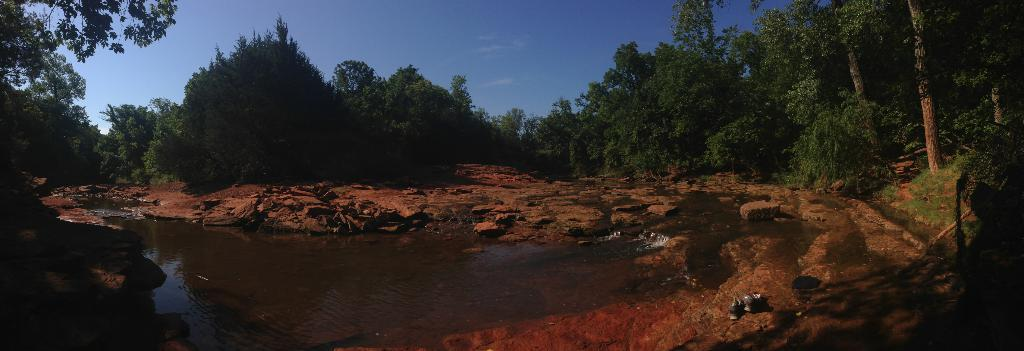What is present at the bottom of the picture? There is water and rocks at the bottom of the picture. What type of natural environment is depicted in the background of the picture? There are many trees in the background of the picture. What is visible at the top of the picture? The sky is visible at the top of the picture. Where is the hall located in the image? There is no hall present in the image; it depicts a natural environment with water, rocks, trees, and sky. How many cherries can be seen on the rocks in the image? There are no cherries present in the image; it features water, rocks, trees, and sky. 